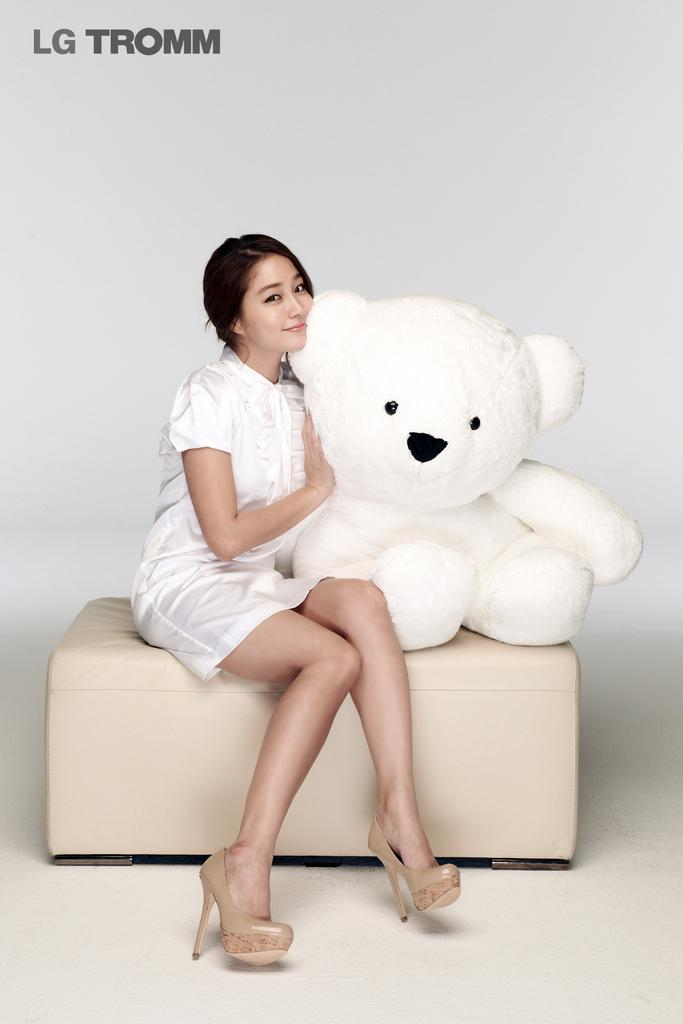Who is the main subject in the image? There is a woman in the image. What is the woman doing in the image? The woman is sitting on a table. What object is the woman holding in the image? The woman is holding a teddy bear. What color is the background of the image? The background of the image is white. How many jellyfish can be seen swimming in the background of the image? There are no jellyfish present in the image; the background is white. What type of animal is sitting next to the woman in the image? There is no animal sitting next to the woman in the image; she is holding a teddy bear. 